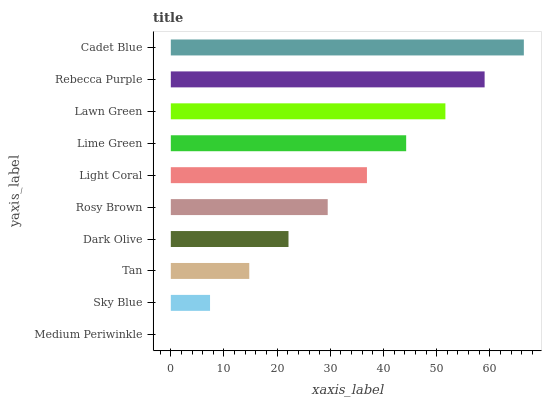Is Medium Periwinkle the minimum?
Answer yes or no. Yes. Is Cadet Blue the maximum?
Answer yes or no. Yes. Is Sky Blue the minimum?
Answer yes or no. No. Is Sky Blue the maximum?
Answer yes or no. No. Is Sky Blue greater than Medium Periwinkle?
Answer yes or no. Yes. Is Medium Periwinkle less than Sky Blue?
Answer yes or no. Yes. Is Medium Periwinkle greater than Sky Blue?
Answer yes or no. No. Is Sky Blue less than Medium Periwinkle?
Answer yes or no. No. Is Light Coral the high median?
Answer yes or no. Yes. Is Rosy Brown the low median?
Answer yes or no. Yes. Is Tan the high median?
Answer yes or no. No. Is Lawn Green the low median?
Answer yes or no. No. 